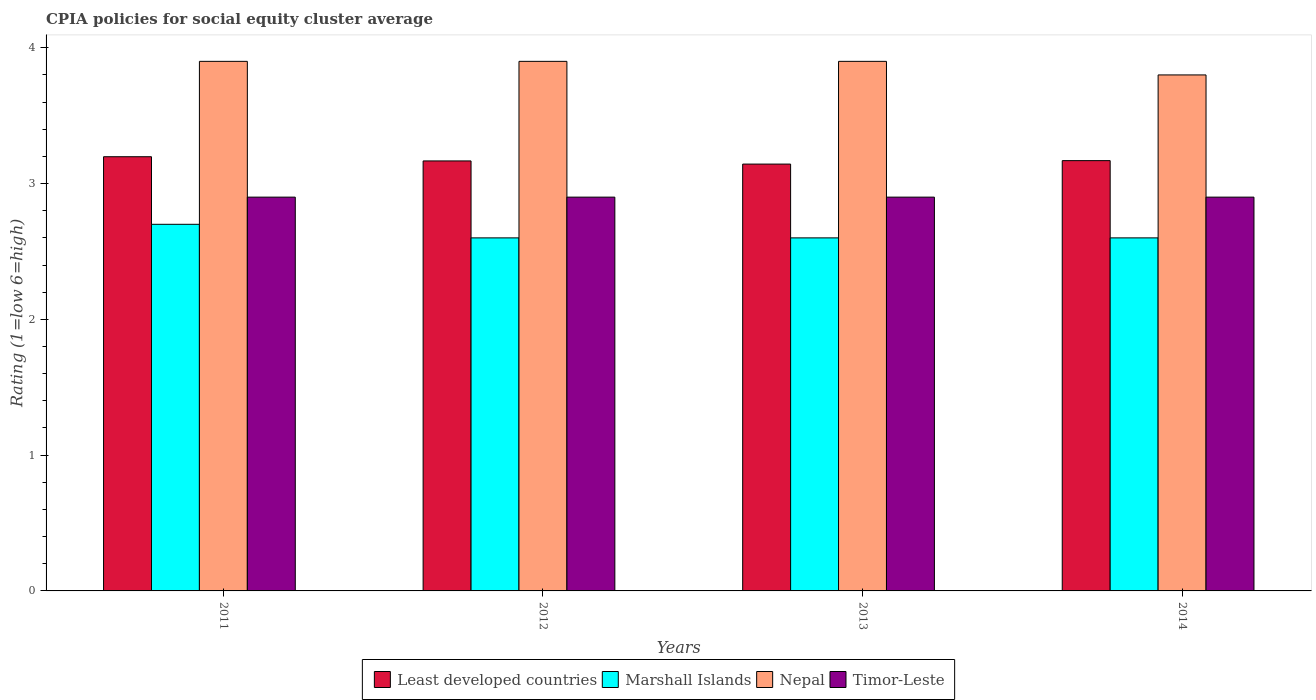How many different coloured bars are there?
Your answer should be very brief. 4. How many groups of bars are there?
Your answer should be compact. 4. Are the number of bars on each tick of the X-axis equal?
Offer a very short reply. Yes. How many bars are there on the 1st tick from the left?
Provide a succinct answer. 4. What is the label of the 1st group of bars from the left?
Your answer should be compact. 2011. What is the CPIA rating in Nepal in 2014?
Provide a short and direct response. 3.8. Across all years, what is the maximum CPIA rating in Marshall Islands?
Offer a very short reply. 2.7. Across all years, what is the minimum CPIA rating in Marshall Islands?
Provide a short and direct response. 2.6. What is the total CPIA rating in Timor-Leste in the graph?
Your answer should be very brief. 11.6. What is the difference between the CPIA rating in Marshall Islands in 2012 and that in 2014?
Ensure brevity in your answer.  0. What is the difference between the CPIA rating in Timor-Leste in 2011 and the CPIA rating in Marshall Islands in 2013?
Offer a terse response. 0.3. What is the average CPIA rating in Least developed countries per year?
Your answer should be very brief. 3.17. In the year 2013, what is the difference between the CPIA rating in Nepal and CPIA rating in Least developed countries?
Make the answer very short. 0.76. In how many years, is the CPIA rating in Least developed countries greater than 2.8?
Provide a short and direct response. 4. What is the ratio of the CPIA rating in Marshall Islands in 2013 to that in 2014?
Your answer should be very brief. 1. Is the CPIA rating in Nepal in 2011 less than that in 2012?
Your answer should be very brief. No. Is the difference between the CPIA rating in Nepal in 2012 and 2014 greater than the difference between the CPIA rating in Least developed countries in 2012 and 2014?
Your response must be concise. Yes. What is the difference between the highest and the second highest CPIA rating in Nepal?
Your response must be concise. 0. What is the difference between the highest and the lowest CPIA rating in Nepal?
Provide a short and direct response. 0.1. In how many years, is the CPIA rating in Nepal greater than the average CPIA rating in Nepal taken over all years?
Make the answer very short. 3. Is it the case that in every year, the sum of the CPIA rating in Timor-Leste and CPIA rating in Nepal is greater than the sum of CPIA rating in Marshall Islands and CPIA rating in Least developed countries?
Keep it short and to the point. Yes. What does the 4th bar from the left in 2013 represents?
Provide a short and direct response. Timor-Leste. What does the 1st bar from the right in 2013 represents?
Provide a short and direct response. Timor-Leste. Is it the case that in every year, the sum of the CPIA rating in Least developed countries and CPIA rating in Timor-Leste is greater than the CPIA rating in Marshall Islands?
Offer a terse response. Yes. How many bars are there?
Provide a short and direct response. 16. Are the values on the major ticks of Y-axis written in scientific E-notation?
Give a very brief answer. No. Does the graph contain any zero values?
Your response must be concise. No. How are the legend labels stacked?
Your response must be concise. Horizontal. What is the title of the graph?
Provide a short and direct response. CPIA policies for social equity cluster average. What is the label or title of the X-axis?
Make the answer very short. Years. What is the label or title of the Y-axis?
Offer a very short reply. Rating (1=low 6=high). What is the Rating (1=low 6=high) of Least developed countries in 2011?
Provide a succinct answer. 3.2. What is the Rating (1=low 6=high) in Least developed countries in 2012?
Ensure brevity in your answer.  3.17. What is the Rating (1=low 6=high) of Nepal in 2012?
Keep it short and to the point. 3.9. What is the Rating (1=low 6=high) in Least developed countries in 2013?
Provide a succinct answer. 3.14. What is the Rating (1=low 6=high) of Marshall Islands in 2013?
Offer a terse response. 2.6. What is the Rating (1=low 6=high) of Nepal in 2013?
Provide a short and direct response. 3.9. What is the Rating (1=low 6=high) of Timor-Leste in 2013?
Provide a short and direct response. 2.9. What is the Rating (1=low 6=high) in Least developed countries in 2014?
Your answer should be compact. 3.17. What is the Rating (1=low 6=high) of Marshall Islands in 2014?
Keep it short and to the point. 2.6. What is the Rating (1=low 6=high) of Nepal in 2014?
Provide a succinct answer. 3.8. What is the Rating (1=low 6=high) in Timor-Leste in 2014?
Offer a terse response. 2.9. Across all years, what is the maximum Rating (1=low 6=high) in Least developed countries?
Your answer should be compact. 3.2. Across all years, what is the maximum Rating (1=low 6=high) of Marshall Islands?
Keep it short and to the point. 2.7. Across all years, what is the maximum Rating (1=low 6=high) in Nepal?
Your answer should be compact. 3.9. Across all years, what is the minimum Rating (1=low 6=high) in Least developed countries?
Keep it short and to the point. 3.14. Across all years, what is the minimum Rating (1=low 6=high) in Marshall Islands?
Your answer should be very brief. 2.6. Across all years, what is the minimum Rating (1=low 6=high) in Timor-Leste?
Your answer should be compact. 2.9. What is the total Rating (1=low 6=high) in Least developed countries in the graph?
Offer a terse response. 12.68. What is the total Rating (1=low 6=high) in Nepal in the graph?
Keep it short and to the point. 15.5. What is the total Rating (1=low 6=high) in Timor-Leste in the graph?
Make the answer very short. 11.6. What is the difference between the Rating (1=low 6=high) of Least developed countries in 2011 and that in 2012?
Provide a succinct answer. 0.03. What is the difference between the Rating (1=low 6=high) of Marshall Islands in 2011 and that in 2012?
Your response must be concise. 0.1. What is the difference between the Rating (1=low 6=high) in Least developed countries in 2011 and that in 2013?
Your response must be concise. 0.05. What is the difference between the Rating (1=low 6=high) in Least developed countries in 2011 and that in 2014?
Provide a succinct answer. 0.03. What is the difference between the Rating (1=low 6=high) in Marshall Islands in 2011 and that in 2014?
Give a very brief answer. 0.1. What is the difference between the Rating (1=low 6=high) of Least developed countries in 2012 and that in 2013?
Keep it short and to the point. 0.02. What is the difference between the Rating (1=low 6=high) of Marshall Islands in 2012 and that in 2013?
Keep it short and to the point. 0. What is the difference between the Rating (1=low 6=high) in Least developed countries in 2012 and that in 2014?
Give a very brief answer. -0. What is the difference between the Rating (1=low 6=high) of Nepal in 2012 and that in 2014?
Give a very brief answer. 0.1. What is the difference between the Rating (1=low 6=high) of Least developed countries in 2013 and that in 2014?
Make the answer very short. -0.03. What is the difference between the Rating (1=low 6=high) of Marshall Islands in 2013 and that in 2014?
Keep it short and to the point. 0. What is the difference between the Rating (1=low 6=high) of Least developed countries in 2011 and the Rating (1=low 6=high) of Marshall Islands in 2012?
Make the answer very short. 0.6. What is the difference between the Rating (1=low 6=high) of Least developed countries in 2011 and the Rating (1=low 6=high) of Nepal in 2012?
Give a very brief answer. -0.7. What is the difference between the Rating (1=low 6=high) in Least developed countries in 2011 and the Rating (1=low 6=high) in Timor-Leste in 2012?
Your response must be concise. 0.3. What is the difference between the Rating (1=low 6=high) of Marshall Islands in 2011 and the Rating (1=low 6=high) of Timor-Leste in 2012?
Keep it short and to the point. -0.2. What is the difference between the Rating (1=low 6=high) in Least developed countries in 2011 and the Rating (1=low 6=high) in Marshall Islands in 2013?
Make the answer very short. 0.6. What is the difference between the Rating (1=low 6=high) in Least developed countries in 2011 and the Rating (1=low 6=high) in Nepal in 2013?
Your answer should be very brief. -0.7. What is the difference between the Rating (1=low 6=high) in Least developed countries in 2011 and the Rating (1=low 6=high) in Timor-Leste in 2013?
Give a very brief answer. 0.3. What is the difference between the Rating (1=low 6=high) of Marshall Islands in 2011 and the Rating (1=low 6=high) of Nepal in 2013?
Keep it short and to the point. -1.2. What is the difference between the Rating (1=low 6=high) of Marshall Islands in 2011 and the Rating (1=low 6=high) of Timor-Leste in 2013?
Keep it short and to the point. -0.2. What is the difference between the Rating (1=low 6=high) of Least developed countries in 2011 and the Rating (1=low 6=high) of Marshall Islands in 2014?
Ensure brevity in your answer.  0.6. What is the difference between the Rating (1=low 6=high) of Least developed countries in 2011 and the Rating (1=low 6=high) of Nepal in 2014?
Ensure brevity in your answer.  -0.6. What is the difference between the Rating (1=low 6=high) in Least developed countries in 2011 and the Rating (1=low 6=high) in Timor-Leste in 2014?
Give a very brief answer. 0.3. What is the difference between the Rating (1=low 6=high) of Nepal in 2011 and the Rating (1=low 6=high) of Timor-Leste in 2014?
Give a very brief answer. 1. What is the difference between the Rating (1=low 6=high) of Least developed countries in 2012 and the Rating (1=low 6=high) of Marshall Islands in 2013?
Make the answer very short. 0.57. What is the difference between the Rating (1=low 6=high) of Least developed countries in 2012 and the Rating (1=low 6=high) of Nepal in 2013?
Your response must be concise. -0.73. What is the difference between the Rating (1=low 6=high) of Least developed countries in 2012 and the Rating (1=low 6=high) of Timor-Leste in 2013?
Make the answer very short. 0.27. What is the difference between the Rating (1=low 6=high) in Marshall Islands in 2012 and the Rating (1=low 6=high) in Nepal in 2013?
Ensure brevity in your answer.  -1.3. What is the difference between the Rating (1=low 6=high) of Least developed countries in 2012 and the Rating (1=low 6=high) of Marshall Islands in 2014?
Ensure brevity in your answer.  0.57. What is the difference between the Rating (1=low 6=high) of Least developed countries in 2012 and the Rating (1=low 6=high) of Nepal in 2014?
Give a very brief answer. -0.63. What is the difference between the Rating (1=low 6=high) of Least developed countries in 2012 and the Rating (1=low 6=high) of Timor-Leste in 2014?
Keep it short and to the point. 0.27. What is the difference between the Rating (1=low 6=high) in Marshall Islands in 2012 and the Rating (1=low 6=high) in Timor-Leste in 2014?
Keep it short and to the point. -0.3. What is the difference between the Rating (1=low 6=high) of Least developed countries in 2013 and the Rating (1=low 6=high) of Marshall Islands in 2014?
Provide a short and direct response. 0.54. What is the difference between the Rating (1=low 6=high) of Least developed countries in 2013 and the Rating (1=low 6=high) of Nepal in 2014?
Offer a terse response. -0.66. What is the difference between the Rating (1=low 6=high) in Least developed countries in 2013 and the Rating (1=low 6=high) in Timor-Leste in 2014?
Your answer should be very brief. 0.24. What is the difference between the Rating (1=low 6=high) in Marshall Islands in 2013 and the Rating (1=low 6=high) in Nepal in 2014?
Offer a terse response. -1.2. What is the average Rating (1=low 6=high) of Least developed countries per year?
Offer a very short reply. 3.17. What is the average Rating (1=low 6=high) in Marshall Islands per year?
Ensure brevity in your answer.  2.62. What is the average Rating (1=low 6=high) in Nepal per year?
Offer a very short reply. 3.88. In the year 2011, what is the difference between the Rating (1=low 6=high) in Least developed countries and Rating (1=low 6=high) in Marshall Islands?
Your response must be concise. 0.5. In the year 2011, what is the difference between the Rating (1=low 6=high) of Least developed countries and Rating (1=low 6=high) of Nepal?
Your response must be concise. -0.7. In the year 2011, what is the difference between the Rating (1=low 6=high) of Least developed countries and Rating (1=low 6=high) of Timor-Leste?
Your answer should be compact. 0.3. In the year 2011, what is the difference between the Rating (1=low 6=high) in Marshall Islands and Rating (1=low 6=high) in Nepal?
Provide a succinct answer. -1.2. In the year 2011, what is the difference between the Rating (1=low 6=high) of Nepal and Rating (1=low 6=high) of Timor-Leste?
Offer a very short reply. 1. In the year 2012, what is the difference between the Rating (1=low 6=high) of Least developed countries and Rating (1=low 6=high) of Marshall Islands?
Offer a very short reply. 0.57. In the year 2012, what is the difference between the Rating (1=low 6=high) of Least developed countries and Rating (1=low 6=high) of Nepal?
Your answer should be compact. -0.73. In the year 2012, what is the difference between the Rating (1=low 6=high) of Least developed countries and Rating (1=low 6=high) of Timor-Leste?
Give a very brief answer. 0.27. In the year 2012, what is the difference between the Rating (1=low 6=high) in Marshall Islands and Rating (1=low 6=high) in Timor-Leste?
Make the answer very short. -0.3. In the year 2012, what is the difference between the Rating (1=low 6=high) in Nepal and Rating (1=low 6=high) in Timor-Leste?
Your answer should be very brief. 1. In the year 2013, what is the difference between the Rating (1=low 6=high) in Least developed countries and Rating (1=low 6=high) in Marshall Islands?
Keep it short and to the point. 0.54. In the year 2013, what is the difference between the Rating (1=low 6=high) in Least developed countries and Rating (1=low 6=high) in Nepal?
Offer a terse response. -0.76. In the year 2013, what is the difference between the Rating (1=low 6=high) in Least developed countries and Rating (1=low 6=high) in Timor-Leste?
Your answer should be very brief. 0.24. In the year 2013, what is the difference between the Rating (1=low 6=high) in Marshall Islands and Rating (1=low 6=high) in Timor-Leste?
Offer a terse response. -0.3. In the year 2014, what is the difference between the Rating (1=low 6=high) of Least developed countries and Rating (1=low 6=high) of Marshall Islands?
Your answer should be very brief. 0.57. In the year 2014, what is the difference between the Rating (1=low 6=high) in Least developed countries and Rating (1=low 6=high) in Nepal?
Offer a terse response. -0.63. In the year 2014, what is the difference between the Rating (1=low 6=high) of Least developed countries and Rating (1=low 6=high) of Timor-Leste?
Provide a short and direct response. 0.27. In the year 2014, what is the difference between the Rating (1=low 6=high) of Marshall Islands and Rating (1=low 6=high) of Nepal?
Your answer should be very brief. -1.2. In the year 2014, what is the difference between the Rating (1=low 6=high) in Marshall Islands and Rating (1=low 6=high) in Timor-Leste?
Keep it short and to the point. -0.3. What is the ratio of the Rating (1=low 6=high) in Least developed countries in 2011 to that in 2012?
Your response must be concise. 1.01. What is the ratio of the Rating (1=low 6=high) in Marshall Islands in 2011 to that in 2012?
Ensure brevity in your answer.  1.04. What is the ratio of the Rating (1=low 6=high) of Least developed countries in 2011 to that in 2013?
Offer a very short reply. 1.02. What is the ratio of the Rating (1=low 6=high) in Least developed countries in 2011 to that in 2014?
Offer a very short reply. 1.01. What is the ratio of the Rating (1=low 6=high) of Marshall Islands in 2011 to that in 2014?
Your answer should be very brief. 1.04. What is the ratio of the Rating (1=low 6=high) of Nepal in 2011 to that in 2014?
Offer a very short reply. 1.03. What is the ratio of the Rating (1=low 6=high) of Least developed countries in 2012 to that in 2013?
Your response must be concise. 1.01. What is the ratio of the Rating (1=low 6=high) in Marshall Islands in 2012 to that in 2013?
Offer a very short reply. 1. What is the ratio of the Rating (1=low 6=high) of Nepal in 2012 to that in 2013?
Offer a terse response. 1. What is the ratio of the Rating (1=low 6=high) in Timor-Leste in 2012 to that in 2013?
Offer a terse response. 1. What is the ratio of the Rating (1=low 6=high) in Least developed countries in 2012 to that in 2014?
Make the answer very short. 1. What is the ratio of the Rating (1=low 6=high) in Marshall Islands in 2012 to that in 2014?
Your answer should be very brief. 1. What is the ratio of the Rating (1=low 6=high) in Nepal in 2012 to that in 2014?
Ensure brevity in your answer.  1.03. What is the ratio of the Rating (1=low 6=high) in Timor-Leste in 2012 to that in 2014?
Offer a very short reply. 1. What is the ratio of the Rating (1=low 6=high) of Least developed countries in 2013 to that in 2014?
Your response must be concise. 0.99. What is the ratio of the Rating (1=low 6=high) in Nepal in 2013 to that in 2014?
Give a very brief answer. 1.03. What is the ratio of the Rating (1=low 6=high) of Timor-Leste in 2013 to that in 2014?
Offer a very short reply. 1. What is the difference between the highest and the second highest Rating (1=low 6=high) of Least developed countries?
Make the answer very short. 0.03. What is the difference between the highest and the second highest Rating (1=low 6=high) in Nepal?
Offer a very short reply. 0. What is the difference between the highest and the second highest Rating (1=low 6=high) in Timor-Leste?
Ensure brevity in your answer.  0. What is the difference between the highest and the lowest Rating (1=low 6=high) of Least developed countries?
Make the answer very short. 0.05. What is the difference between the highest and the lowest Rating (1=low 6=high) of Marshall Islands?
Keep it short and to the point. 0.1. What is the difference between the highest and the lowest Rating (1=low 6=high) in Nepal?
Make the answer very short. 0.1. What is the difference between the highest and the lowest Rating (1=low 6=high) in Timor-Leste?
Offer a terse response. 0. 